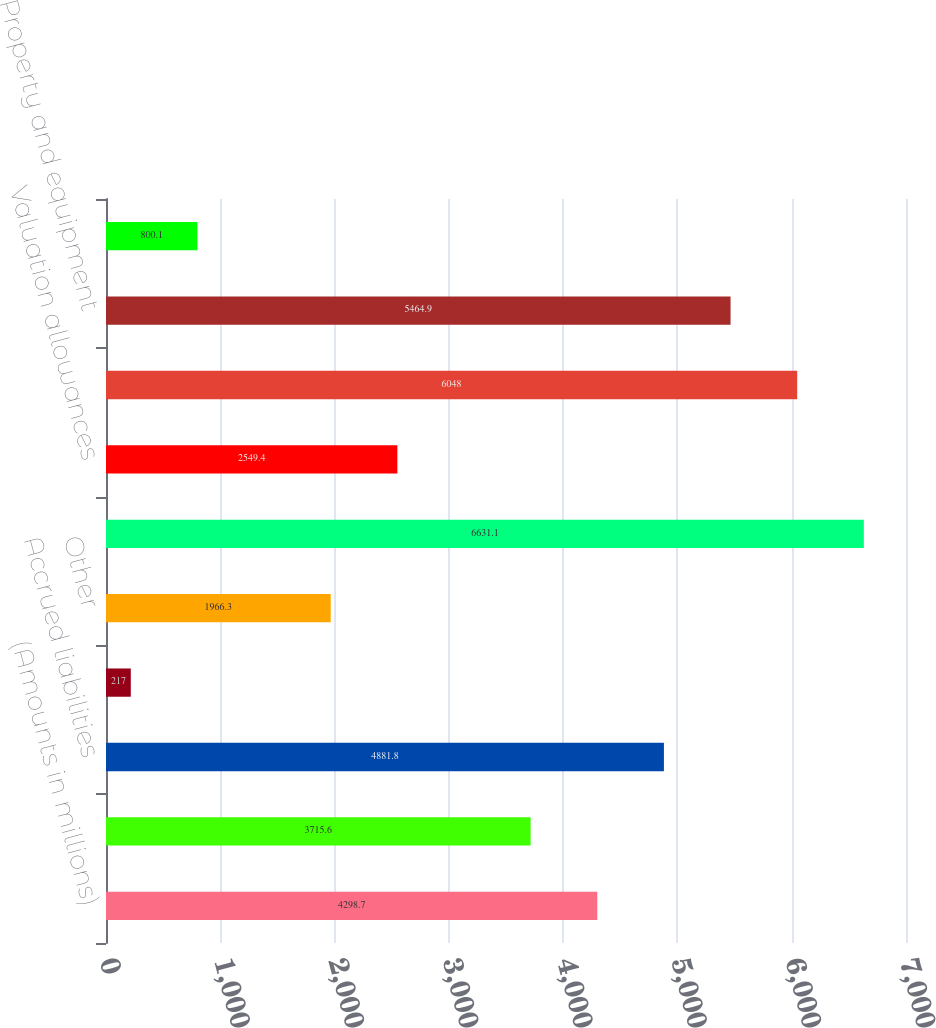Convert chart. <chart><loc_0><loc_0><loc_500><loc_500><bar_chart><fcel>(Amounts in millions)<fcel>Loss and tax credit<fcel>Accrued liabilities<fcel>Share-based compensation<fcel>Other<fcel>Total deferred tax assets<fcel>Valuation allowances<fcel>Deferred tax assets net of<fcel>Property and equipment<fcel>Acquired intangibles<nl><fcel>4298.7<fcel>3715.6<fcel>4881.8<fcel>217<fcel>1966.3<fcel>6631.1<fcel>2549.4<fcel>6048<fcel>5464.9<fcel>800.1<nl></chart> 